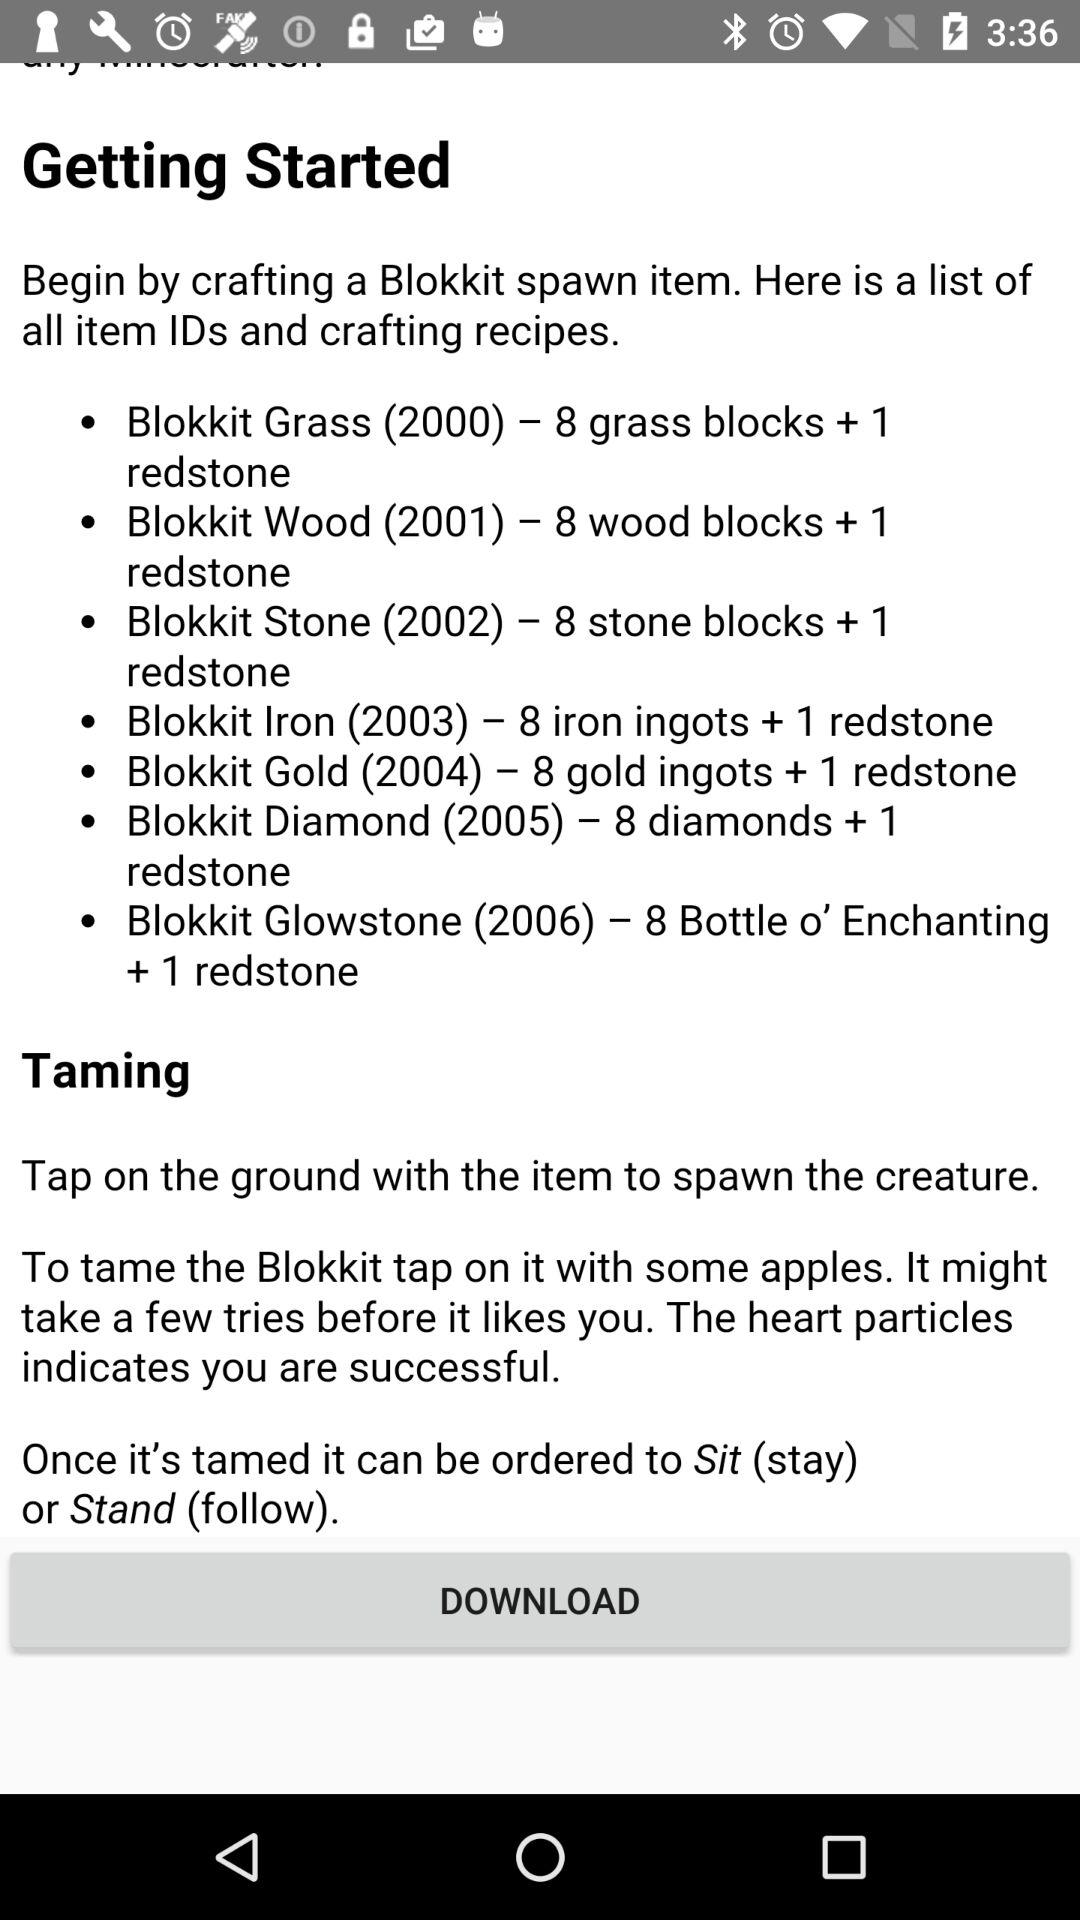How many different Blokkit spawn items are there?
Answer the question using a single word or phrase. 7 